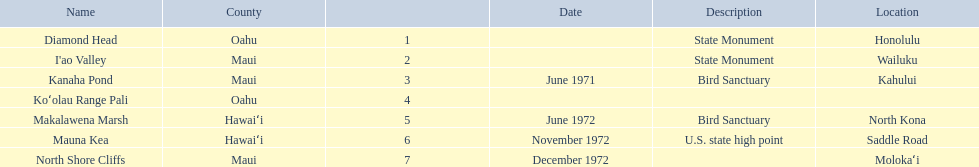What are all of the landmark names? Diamond Head, I'ao Valley, Kanaha Pond, Koʻolau Range Pali, Makalawena Marsh, Mauna Kea, North Shore Cliffs. Where are they located? Honolulu, Wailuku, Kahului, , North Kona, Saddle Road, Molokaʻi. And which landmark has no listed location? Koʻolau Range Pali. What are all of the landmark names in hawaii? Diamond Head, I'ao Valley, Kanaha Pond, Koʻolau Range Pali, Makalawena Marsh, Mauna Kea, North Shore Cliffs. What are their descriptions? State Monument, State Monument, Bird Sanctuary, , Bird Sanctuary, U.S. state high point, . And which is described as a u.s. state high point? Mauna Kea. 